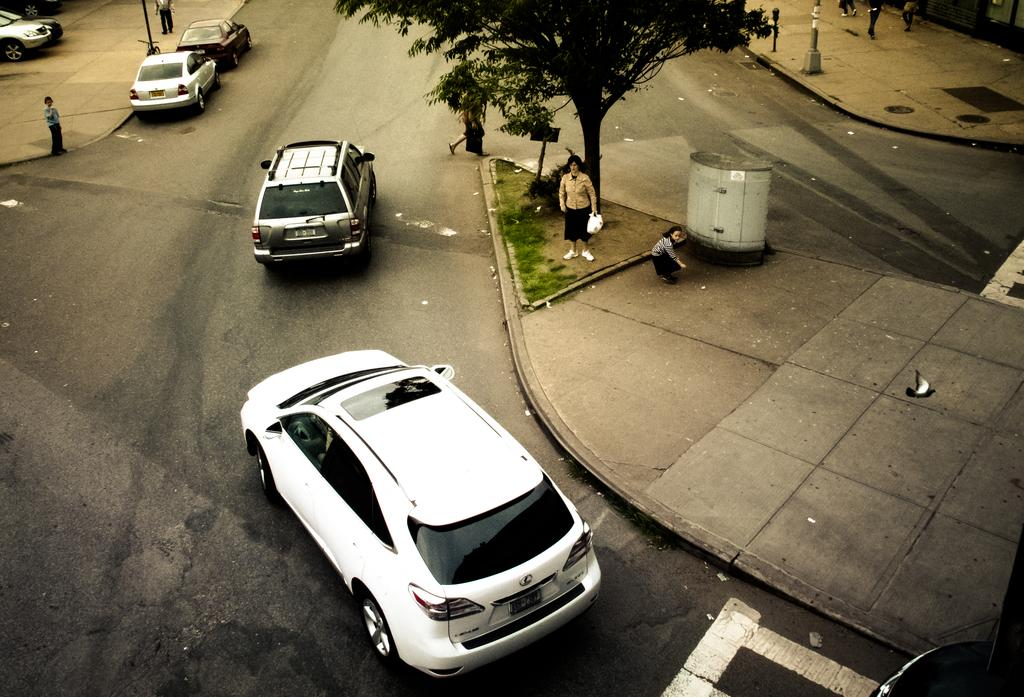What can be seen on the road in the image? There are fleets of cars on the road in the image. How many people are present in the image? There are five persons in the image. What is visible in the background of the image? There is a tree, grass, and poles in the background of the image. Where was the image taken? The image was taken on the road. What type of songs can be heard playing from the selection of music in the image? There is no music or selection of music present in the image; it features fleets of cars on the road and people. 